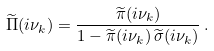Convert formula to latex. <formula><loc_0><loc_0><loc_500><loc_500>\widetilde { \Pi } ( i \nu _ { k } ) = \frac { \widetilde { \pi } ( i \nu _ { k } ) } { 1 - \widetilde { \pi } ( i \nu _ { k } ) \, \widetilde { \sigma } ( i \nu _ { k } ) } \, .</formula> 